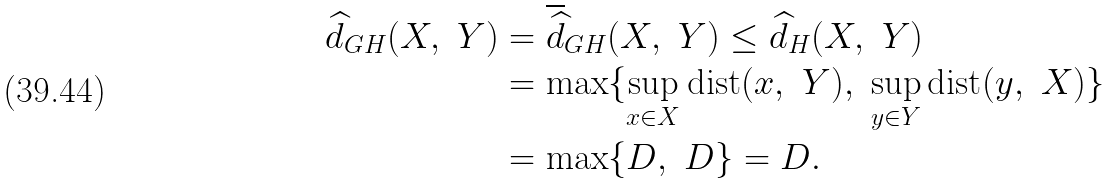<formula> <loc_0><loc_0><loc_500><loc_500>\widehat { d } _ { G H } ( X , \ Y ) & = \overline { \widehat { d } } _ { G H } ( X , \ Y ) \leq \widehat { d } _ { H } ( X , \ Y ) \\ & = \max \{ \sup _ { x \in X } \text {dist} ( x , \ Y ) , \ \sup _ { y \in Y } \text {dist} ( y , \ X ) \} \\ & = \max \{ D , \ D \} = D .</formula> 